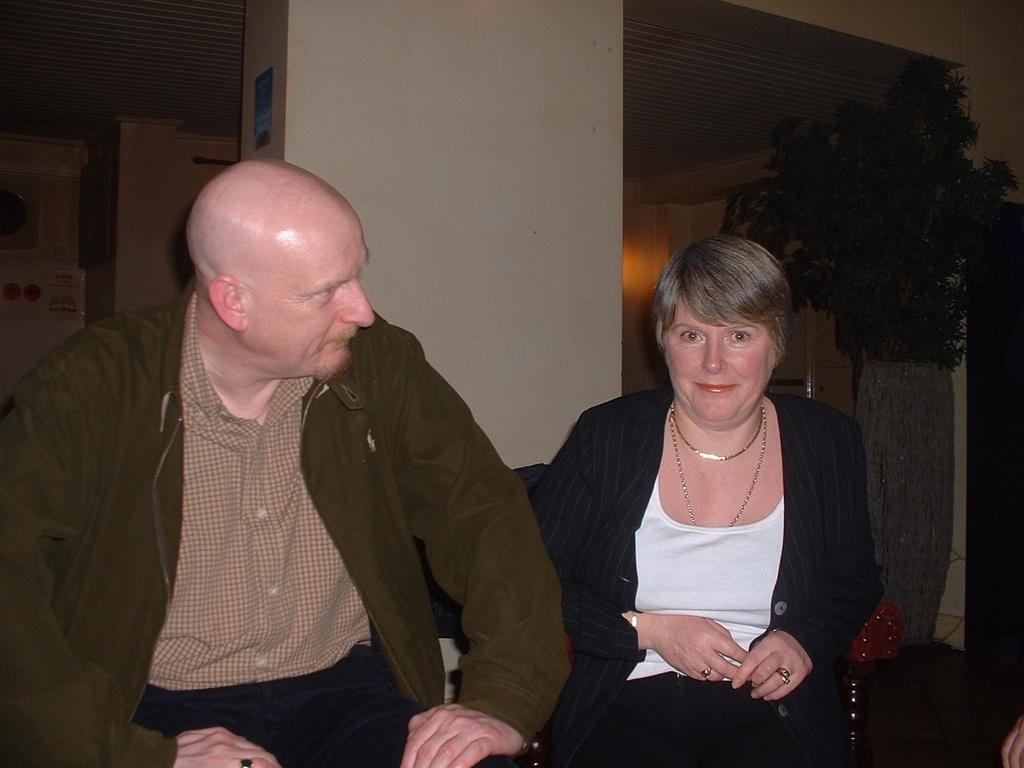Who is present in the image? There is a woman and a man in the image. What is the woman doing in the image? The woman is smiling in the image. What can be seen in the background of the image? There are pillars, a ceiling, leaves, posters, and some objects visible in the background of the image. How many dogs are present in the image? There are no dogs present in the image. What type of body is visible in the image? There is no specific body visible in the image; it features a woman and a man, but their bodies are not the main focus of the image. 